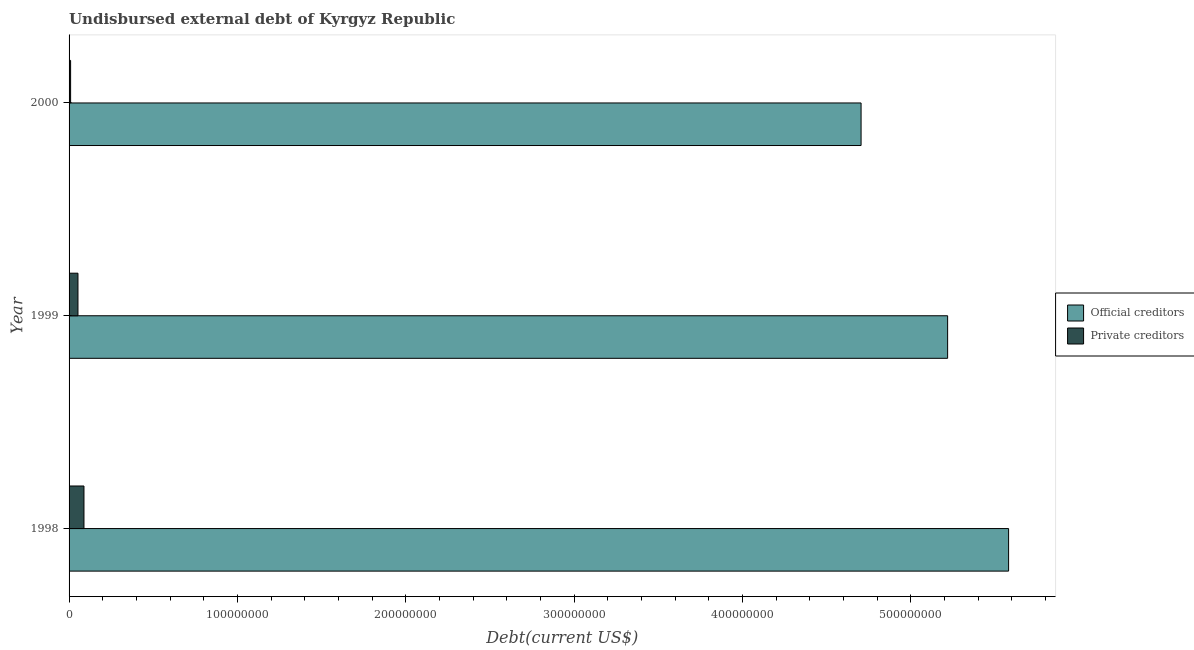How many different coloured bars are there?
Your response must be concise. 2. Are the number of bars on each tick of the Y-axis equal?
Your response must be concise. Yes. What is the undisbursed external debt of private creditors in 1999?
Keep it short and to the point. 5.28e+06. Across all years, what is the maximum undisbursed external debt of official creditors?
Give a very brief answer. 5.58e+08. Across all years, what is the minimum undisbursed external debt of official creditors?
Your answer should be very brief. 4.70e+08. In which year was the undisbursed external debt of private creditors maximum?
Give a very brief answer. 1998. In which year was the undisbursed external debt of official creditors minimum?
Keep it short and to the point. 2000. What is the total undisbursed external debt of private creditors in the graph?
Give a very brief answer. 1.50e+07. What is the difference between the undisbursed external debt of private creditors in 1999 and that in 2000?
Your response must be concise. 4.37e+06. What is the difference between the undisbursed external debt of official creditors in 2000 and the undisbursed external debt of private creditors in 1999?
Make the answer very short. 4.65e+08. What is the average undisbursed external debt of official creditors per year?
Keep it short and to the point. 5.17e+08. In the year 1998, what is the difference between the undisbursed external debt of private creditors and undisbursed external debt of official creditors?
Provide a succinct answer. -5.49e+08. In how many years, is the undisbursed external debt of private creditors greater than 80000000 US$?
Provide a succinct answer. 0. What is the ratio of the undisbursed external debt of private creditors in 1998 to that in 1999?
Provide a succinct answer. 1.68. Is the undisbursed external debt of official creditors in 1998 less than that in 2000?
Your response must be concise. No. What is the difference between the highest and the second highest undisbursed external debt of private creditors?
Your response must be concise. 3.57e+06. What is the difference between the highest and the lowest undisbursed external debt of private creditors?
Offer a terse response. 7.94e+06. Is the sum of the undisbursed external debt of private creditors in 1999 and 2000 greater than the maximum undisbursed external debt of official creditors across all years?
Your answer should be very brief. No. What does the 1st bar from the top in 1998 represents?
Keep it short and to the point. Private creditors. What does the 1st bar from the bottom in 1998 represents?
Give a very brief answer. Official creditors. How many years are there in the graph?
Offer a very short reply. 3. What is the difference between two consecutive major ticks on the X-axis?
Provide a succinct answer. 1.00e+08. How many legend labels are there?
Give a very brief answer. 2. What is the title of the graph?
Provide a succinct answer. Undisbursed external debt of Kyrgyz Republic. What is the label or title of the X-axis?
Your response must be concise. Debt(current US$). What is the Debt(current US$) of Official creditors in 1998?
Provide a succinct answer. 5.58e+08. What is the Debt(current US$) of Private creditors in 1998?
Your answer should be compact. 8.85e+06. What is the Debt(current US$) of Official creditors in 1999?
Give a very brief answer. 5.22e+08. What is the Debt(current US$) in Private creditors in 1999?
Provide a short and direct response. 5.28e+06. What is the Debt(current US$) of Official creditors in 2000?
Provide a succinct answer. 4.70e+08. What is the Debt(current US$) of Private creditors in 2000?
Your response must be concise. 9.12e+05. Across all years, what is the maximum Debt(current US$) of Official creditors?
Ensure brevity in your answer.  5.58e+08. Across all years, what is the maximum Debt(current US$) in Private creditors?
Provide a short and direct response. 8.85e+06. Across all years, what is the minimum Debt(current US$) in Official creditors?
Give a very brief answer. 4.70e+08. Across all years, what is the minimum Debt(current US$) of Private creditors?
Your response must be concise. 9.12e+05. What is the total Debt(current US$) in Official creditors in the graph?
Your answer should be compact. 1.55e+09. What is the total Debt(current US$) in Private creditors in the graph?
Ensure brevity in your answer.  1.50e+07. What is the difference between the Debt(current US$) in Official creditors in 1998 and that in 1999?
Give a very brief answer. 3.62e+07. What is the difference between the Debt(current US$) of Private creditors in 1998 and that in 1999?
Give a very brief answer. 3.57e+06. What is the difference between the Debt(current US$) in Official creditors in 1998 and that in 2000?
Make the answer very short. 8.76e+07. What is the difference between the Debt(current US$) in Private creditors in 1998 and that in 2000?
Your answer should be very brief. 7.94e+06. What is the difference between the Debt(current US$) of Official creditors in 1999 and that in 2000?
Make the answer very short. 5.14e+07. What is the difference between the Debt(current US$) of Private creditors in 1999 and that in 2000?
Make the answer very short. 4.37e+06. What is the difference between the Debt(current US$) of Official creditors in 1998 and the Debt(current US$) of Private creditors in 1999?
Offer a very short reply. 5.53e+08. What is the difference between the Debt(current US$) in Official creditors in 1998 and the Debt(current US$) in Private creditors in 2000?
Give a very brief answer. 5.57e+08. What is the difference between the Debt(current US$) in Official creditors in 1999 and the Debt(current US$) in Private creditors in 2000?
Give a very brief answer. 5.21e+08. What is the average Debt(current US$) in Official creditors per year?
Your answer should be compact. 5.17e+08. What is the average Debt(current US$) in Private creditors per year?
Provide a short and direct response. 5.02e+06. In the year 1998, what is the difference between the Debt(current US$) of Official creditors and Debt(current US$) of Private creditors?
Provide a succinct answer. 5.49e+08. In the year 1999, what is the difference between the Debt(current US$) in Official creditors and Debt(current US$) in Private creditors?
Your response must be concise. 5.17e+08. In the year 2000, what is the difference between the Debt(current US$) of Official creditors and Debt(current US$) of Private creditors?
Ensure brevity in your answer.  4.70e+08. What is the ratio of the Debt(current US$) in Official creditors in 1998 to that in 1999?
Provide a short and direct response. 1.07. What is the ratio of the Debt(current US$) of Private creditors in 1998 to that in 1999?
Offer a terse response. 1.68. What is the ratio of the Debt(current US$) of Official creditors in 1998 to that in 2000?
Your answer should be compact. 1.19. What is the ratio of the Debt(current US$) in Private creditors in 1998 to that in 2000?
Offer a terse response. 9.71. What is the ratio of the Debt(current US$) in Official creditors in 1999 to that in 2000?
Ensure brevity in your answer.  1.11. What is the ratio of the Debt(current US$) in Private creditors in 1999 to that in 2000?
Keep it short and to the point. 5.79. What is the difference between the highest and the second highest Debt(current US$) of Official creditors?
Provide a succinct answer. 3.62e+07. What is the difference between the highest and the second highest Debt(current US$) of Private creditors?
Keep it short and to the point. 3.57e+06. What is the difference between the highest and the lowest Debt(current US$) of Official creditors?
Make the answer very short. 8.76e+07. What is the difference between the highest and the lowest Debt(current US$) in Private creditors?
Give a very brief answer. 7.94e+06. 